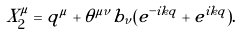<formula> <loc_0><loc_0><loc_500><loc_500>X _ { 2 } ^ { \mu } = q ^ { \mu } + \theta ^ { \mu \nu } b _ { \nu } ( e ^ { - i k q } + e ^ { i k q } ) .</formula> 